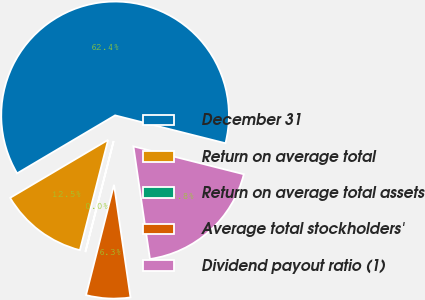Convert chart. <chart><loc_0><loc_0><loc_500><loc_500><pie_chart><fcel>December 31<fcel>Return on average total<fcel>Return on average total assets<fcel>Average total stockholders'<fcel>Dividend payout ratio (1)<nl><fcel>62.44%<fcel>12.51%<fcel>0.03%<fcel>6.27%<fcel>18.75%<nl></chart> 